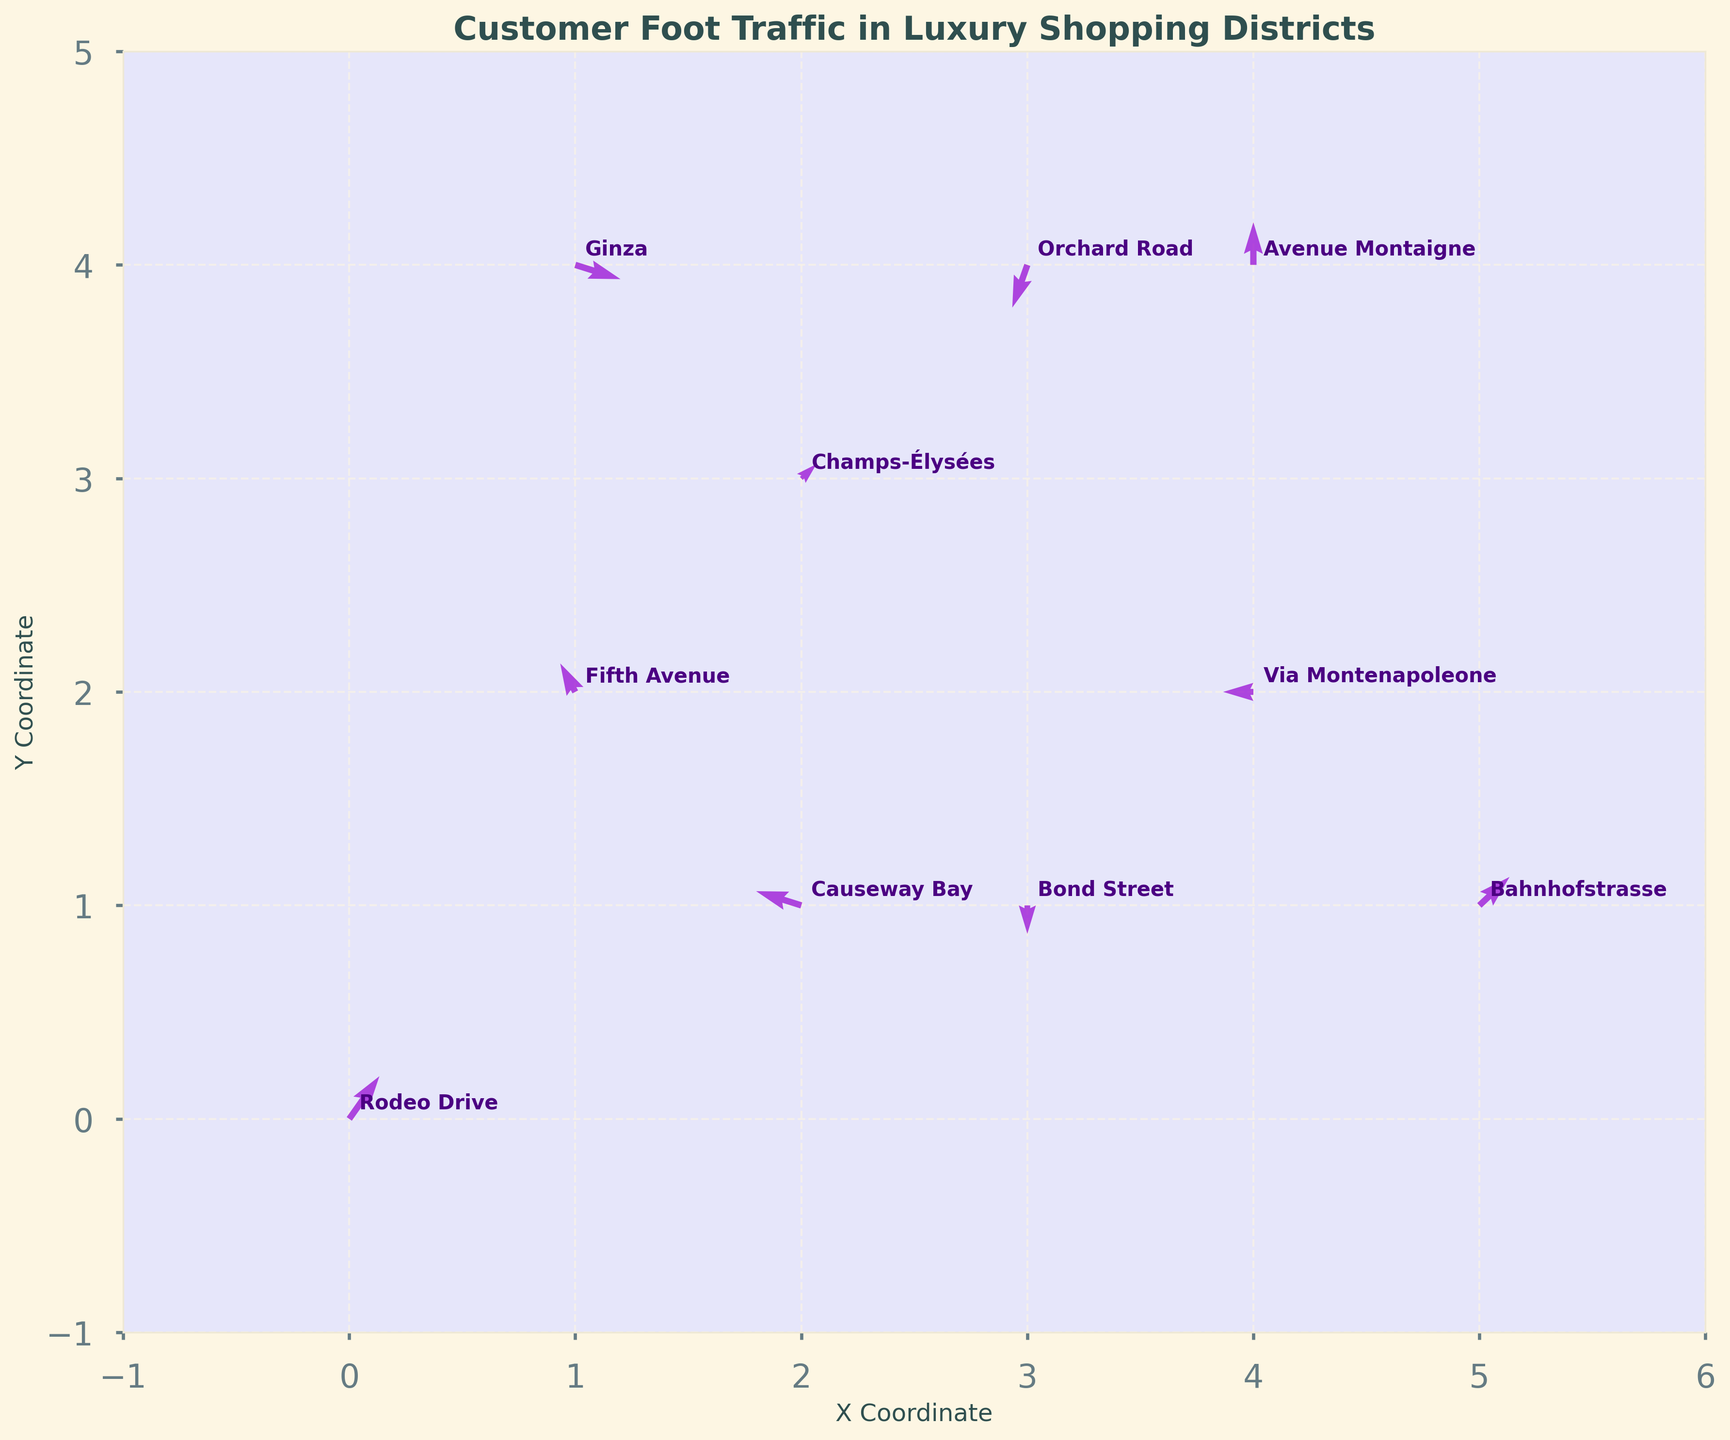What is the title of the plot? The title is usually displayed at the top of the plot. In this case, it is explicitly stated to be 'Customer Foot Traffic in Luxury Shopping Districts'.
Answer: 'Customer Foot Traffic in Luxury Shopping Districts' Which location has the highest foot traffic in the eastward direction? To answer this, look for the longest arrow pointing to the right (positive x-direction). Bahnhofstrasse has the longest arrow pointing to the right.
Answer: Bahnhofstrasse What are the coordinates for Fifth Avenue and Champs-Élysées? Identify the annotations for Fifth Avenue and Champs-Élysées, and note the corresponding coordinates from the quiver plot. Fifth Avenue is at (1, 2) and Champs-Élysées is at (2, 3).
Answer: Fifth Avenue: (1, 2), Champs-Élysées: (2, 3) Which luxury shopping district has the largest downward movement? Look for the longest arrow pointing downward (negative y-direction). Bond Street has the longest arrow pointing downward.
Answer: Bond Street Which two locations have the same y-coordinate but different x-coordinates? Locate points that share the same vertical alignment. Bond Street (3, 1) and Causeway Bay (2, 1) both have a y-coordinate of 1.
Answer: Bond Street and Causeway Bay Which location has the least movement in terms of distance and what indicates this? Identify the shortest arrow in the plot, indicating the least movement. Bond Street has the least movement as it has a zero x-component and a -2 y-component.
Answer: Bond Street By how much does the foot traffic at Rodeo Drive increase in the y-direction? Observe the arrow at Rodeo Drive. It moves 3 units in the y-direction.
Answer: 3 units Which locations have negative x-direction traffic and how does their foot traffic compare in that direction? Identify locations with arrows pointing left (negative x-direction): Fifth Avenue (-1), Via Montenapoleone (-2), Orchard Road (-1), and Causeway Bay (-3). Compare their x-components. Causeway Bay has the most negative x-direction traffic (-3).
Answer: Fifth Avenue, Via Montenapoleone, Orchard Road, Causeway Bay (Causeway Bay has the most negative x-direction) What is the total increase in y-direction traffic for Avenue Montaigne and Ginza combined? Add the y-components for Avenue Montaigne (3) and Ginza (-1). The total is 3 + (-1) = 2.
Answer: 2 units Which location shows a net movement towards the northwest direction? Look for arrows pointing towards the top-left quadrant (northwest). Both Orchard Road and Bond Street show movement towards the northwest, but Orchard Road has a more pronounced northwest direction.
Answer: Orchard Road 